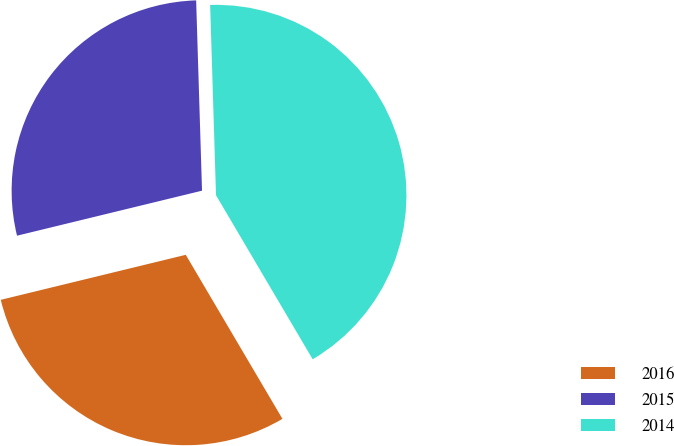<chart> <loc_0><loc_0><loc_500><loc_500><pie_chart><fcel>2016<fcel>2015<fcel>2014<nl><fcel>29.68%<fcel>28.31%<fcel>42.02%<nl></chart> 